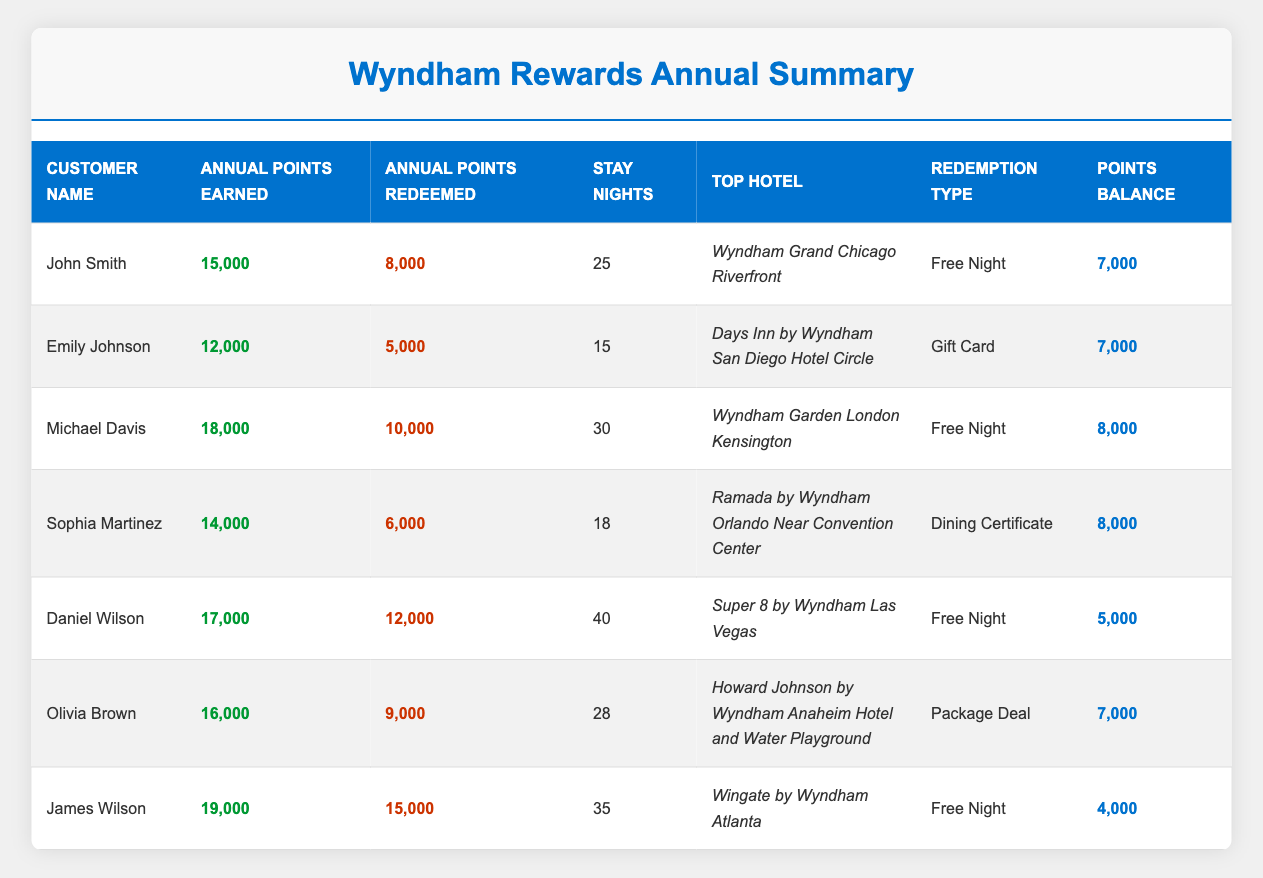What is the total number of annual points earned by all customers? To find the total annual points earned, sum the "Annual Points Earned" values across all customers: 15000 + 12000 + 18000 + 14000 + 17000 + 16000 + 19000 = 111000
Answer: 111000 Who has the highest balance of points remaining? Looking at the "Points Balance" column, the maximum value is 8000, which appears for Michael Davis, Sophia Martinez, and John Smith. Thus, the highest points balance is shared among these three customers.
Answer: Michael Davis, Sophia Martinez, and John Smith How many points did Emily Johnson redeem? The table shows that Emily Johnson redeemed 5000 points as indicated in the "Annual Points Redeemed" column.
Answer: 5000 What is the difference between the points earned and points redeemed for Daniel Wilson? For Daniel Wilson, points earned are 17000 and points redeemed are 12000. Calculate the difference: 17000 - 12000 = 5000.
Answer: 5000 Which redemption type corresponds to Olivia Brown? From the table, Olivia Brown redeemed points for a "Package Deal" as indicated in the "Redemption Type" column.
Answer: Package Deal What is the average annual points earned by the customers in the table? Calculate the total points earned (111000) and divide by the number of customers (7): 111000 / 7 = 15857.14.
Answer: 15857.14 Who stayed the most nights, and how many nights did they stay? The customer with the highest "Stay Nights" is Daniel Wilson, who stayed for 40 nights.
Answer: Daniel Wilson, 40 nights Is the redemption type for Michael Davis a Free Night? Yes, the "Redemption Type" for Michael Davis is listed as "Free Night" in the table.
Answer: Yes How many customers have a points balance below 6000? Review the "Points Balance" column. Only James Wilson has a balance of 4000, which is below 6000.
Answer: 1 What is the total amount of points redeemed by all customers? To find the total points redeemed, sum the "Annual Points Redeemed" values: 8000 + 5000 + 10000 + 6000 + 12000 + 9000 + 15000 = 60000.
Answer: 60000 